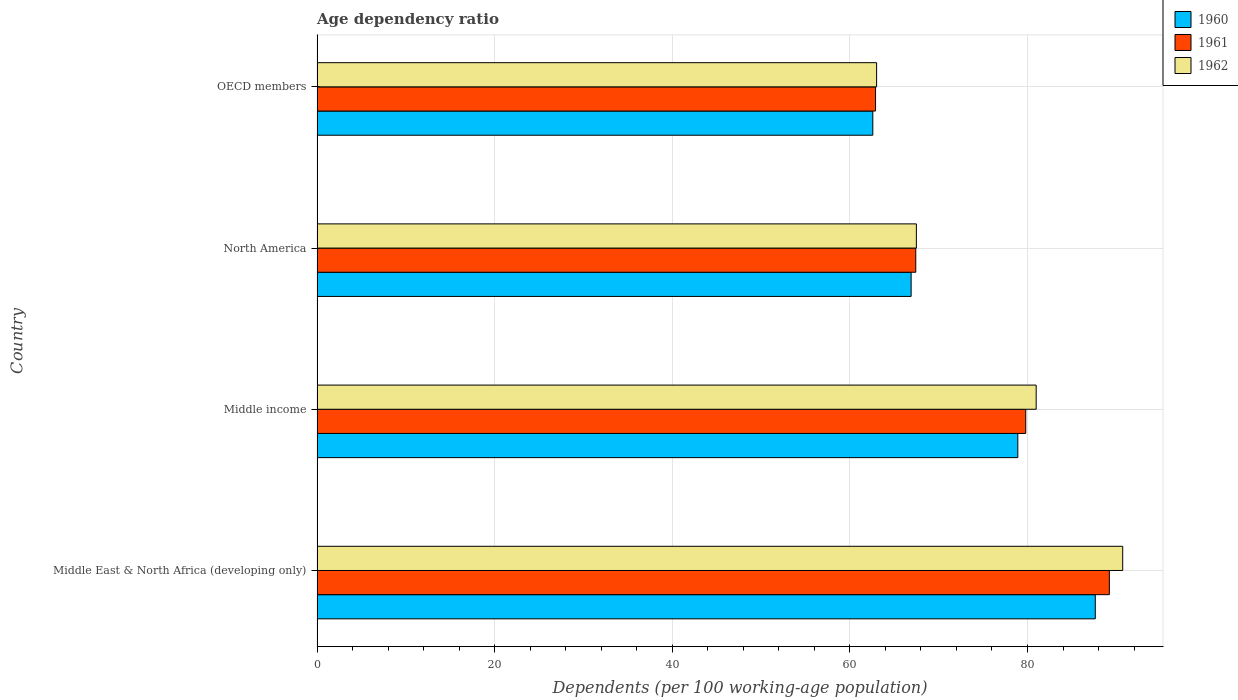How many groups of bars are there?
Your answer should be very brief. 4. Are the number of bars per tick equal to the number of legend labels?
Make the answer very short. Yes. Are the number of bars on each tick of the Y-axis equal?
Offer a terse response. Yes. How many bars are there on the 3rd tick from the top?
Your answer should be compact. 3. What is the label of the 3rd group of bars from the top?
Ensure brevity in your answer.  Middle income. What is the age dependency ratio in in 1962 in Middle East & North Africa (developing only)?
Provide a short and direct response. 90.72. Across all countries, what is the maximum age dependency ratio in in 1960?
Offer a very short reply. 87.64. Across all countries, what is the minimum age dependency ratio in in 1960?
Offer a terse response. 62.58. In which country was the age dependency ratio in in 1962 maximum?
Keep it short and to the point. Middle East & North Africa (developing only). What is the total age dependency ratio in in 1962 in the graph?
Your answer should be very brief. 302.2. What is the difference between the age dependency ratio in in 1961 in Middle East & North Africa (developing only) and that in Middle income?
Ensure brevity in your answer.  9.41. What is the difference between the age dependency ratio in in 1961 in Middle income and the age dependency ratio in in 1962 in OECD members?
Make the answer very short. 16.79. What is the average age dependency ratio in in 1961 per country?
Make the answer very short. 74.83. What is the difference between the age dependency ratio in in 1962 and age dependency ratio in in 1961 in North America?
Your answer should be compact. 0.07. In how many countries, is the age dependency ratio in in 1961 greater than 52 %?
Offer a terse response. 4. What is the ratio of the age dependency ratio in in 1962 in Middle income to that in North America?
Your answer should be compact. 1.2. Is the age dependency ratio in in 1960 in Middle East & North Africa (developing only) less than that in North America?
Keep it short and to the point. No. What is the difference between the highest and the second highest age dependency ratio in in 1961?
Provide a short and direct response. 9.41. What is the difference between the highest and the lowest age dependency ratio in in 1961?
Keep it short and to the point. 26.33. In how many countries, is the age dependency ratio in in 1961 greater than the average age dependency ratio in in 1961 taken over all countries?
Give a very brief answer. 2. What does the 2nd bar from the bottom in North America represents?
Your answer should be very brief. 1961. Is it the case that in every country, the sum of the age dependency ratio in in 1960 and age dependency ratio in in 1961 is greater than the age dependency ratio in in 1962?
Ensure brevity in your answer.  Yes. How many bars are there?
Provide a succinct answer. 12. Are all the bars in the graph horizontal?
Your response must be concise. Yes. What is the difference between two consecutive major ticks on the X-axis?
Keep it short and to the point. 20. How are the legend labels stacked?
Make the answer very short. Vertical. What is the title of the graph?
Provide a succinct answer. Age dependency ratio. What is the label or title of the X-axis?
Offer a very short reply. Dependents (per 100 working-age population). What is the Dependents (per 100 working-age population) in 1960 in Middle East & North Africa (developing only)?
Your answer should be compact. 87.64. What is the Dependents (per 100 working-age population) of 1961 in Middle East & North Africa (developing only)?
Ensure brevity in your answer.  89.22. What is the Dependents (per 100 working-age population) in 1962 in Middle East & North Africa (developing only)?
Give a very brief answer. 90.72. What is the Dependents (per 100 working-age population) in 1960 in Middle income?
Your answer should be very brief. 78.91. What is the Dependents (per 100 working-age population) of 1961 in Middle income?
Make the answer very short. 79.8. What is the Dependents (per 100 working-age population) of 1962 in Middle income?
Your response must be concise. 80.98. What is the Dependents (per 100 working-age population) of 1960 in North America?
Ensure brevity in your answer.  66.9. What is the Dependents (per 100 working-age population) of 1961 in North America?
Your answer should be compact. 67.42. What is the Dependents (per 100 working-age population) in 1962 in North America?
Keep it short and to the point. 67.49. What is the Dependents (per 100 working-age population) in 1960 in OECD members?
Provide a short and direct response. 62.58. What is the Dependents (per 100 working-age population) of 1961 in OECD members?
Your answer should be compact. 62.89. What is the Dependents (per 100 working-age population) in 1962 in OECD members?
Keep it short and to the point. 63.01. Across all countries, what is the maximum Dependents (per 100 working-age population) of 1960?
Your answer should be very brief. 87.64. Across all countries, what is the maximum Dependents (per 100 working-age population) of 1961?
Your answer should be compact. 89.22. Across all countries, what is the maximum Dependents (per 100 working-age population) in 1962?
Make the answer very short. 90.72. Across all countries, what is the minimum Dependents (per 100 working-age population) in 1960?
Provide a succinct answer. 62.58. Across all countries, what is the minimum Dependents (per 100 working-age population) in 1961?
Your answer should be very brief. 62.89. Across all countries, what is the minimum Dependents (per 100 working-age population) in 1962?
Offer a very short reply. 63.01. What is the total Dependents (per 100 working-age population) in 1960 in the graph?
Your response must be concise. 296.03. What is the total Dependents (per 100 working-age population) of 1961 in the graph?
Keep it short and to the point. 299.33. What is the total Dependents (per 100 working-age population) of 1962 in the graph?
Provide a succinct answer. 302.2. What is the difference between the Dependents (per 100 working-age population) of 1960 in Middle East & North Africa (developing only) and that in Middle income?
Provide a succinct answer. 8.72. What is the difference between the Dependents (per 100 working-age population) in 1961 in Middle East & North Africa (developing only) and that in Middle income?
Give a very brief answer. 9.41. What is the difference between the Dependents (per 100 working-age population) in 1962 in Middle East & North Africa (developing only) and that in Middle income?
Your response must be concise. 9.74. What is the difference between the Dependents (per 100 working-age population) of 1960 in Middle East & North Africa (developing only) and that in North America?
Provide a short and direct response. 20.74. What is the difference between the Dependents (per 100 working-age population) in 1961 in Middle East & North Africa (developing only) and that in North America?
Your answer should be very brief. 21.8. What is the difference between the Dependents (per 100 working-age population) in 1962 in Middle East & North Africa (developing only) and that in North America?
Offer a very short reply. 23.23. What is the difference between the Dependents (per 100 working-age population) of 1960 in Middle East & North Africa (developing only) and that in OECD members?
Your answer should be very brief. 25.05. What is the difference between the Dependents (per 100 working-age population) in 1961 in Middle East & North Africa (developing only) and that in OECD members?
Provide a succinct answer. 26.33. What is the difference between the Dependents (per 100 working-age population) of 1962 in Middle East & North Africa (developing only) and that in OECD members?
Your response must be concise. 27.71. What is the difference between the Dependents (per 100 working-age population) of 1960 in Middle income and that in North America?
Ensure brevity in your answer.  12.01. What is the difference between the Dependents (per 100 working-age population) in 1961 in Middle income and that in North America?
Make the answer very short. 12.38. What is the difference between the Dependents (per 100 working-age population) of 1962 in Middle income and that in North America?
Ensure brevity in your answer.  13.49. What is the difference between the Dependents (per 100 working-age population) of 1960 in Middle income and that in OECD members?
Give a very brief answer. 16.33. What is the difference between the Dependents (per 100 working-age population) of 1961 in Middle income and that in OECD members?
Your response must be concise. 16.91. What is the difference between the Dependents (per 100 working-age population) in 1962 in Middle income and that in OECD members?
Your answer should be compact. 17.97. What is the difference between the Dependents (per 100 working-age population) of 1960 in North America and that in OECD members?
Provide a short and direct response. 4.31. What is the difference between the Dependents (per 100 working-age population) of 1961 in North America and that in OECD members?
Your response must be concise. 4.53. What is the difference between the Dependents (per 100 working-age population) of 1962 in North America and that in OECD members?
Ensure brevity in your answer.  4.48. What is the difference between the Dependents (per 100 working-age population) in 1960 in Middle East & North Africa (developing only) and the Dependents (per 100 working-age population) in 1961 in Middle income?
Provide a succinct answer. 7.83. What is the difference between the Dependents (per 100 working-age population) in 1960 in Middle East & North Africa (developing only) and the Dependents (per 100 working-age population) in 1962 in Middle income?
Provide a short and direct response. 6.66. What is the difference between the Dependents (per 100 working-age population) in 1961 in Middle East & North Africa (developing only) and the Dependents (per 100 working-age population) in 1962 in Middle income?
Your answer should be very brief. 8.24. What is the difference between the Dependents (per 100 working-age population) of 1960 in Middle East & North Africa (developing only) and the Dependents (per 100 working-age population) of 1961 in North America?
Provide a succinct answer. 20.22. What is the difference between the Dependents (per 100 working-age population) of 1960 in Middle East & North Africa (developing only) and the Dependents (per 100 working-age population) of 1962 in North America?
Offer a very short reply. 20.15. What is the difference between the Dependents (per 100 working-age population) of 1961 in Middle East & North Africa (developing only) and the Dependents (per 100 working-age population) of 1962 in North America?
Offer a terse response. 21.73. What is the difference between the Dependents (per 100 working-age population) in 1960 in Middle East & North Africa (developing only) and the Dependents (per 100 working-age population) in 1961 in OECD members?
Provide a succinct answer. 24.74. What is the difference between the Dependents (per 100 working-age population) in 1960 in Middle East & North Africa (developing only) and the Dependents (per 100 working-age population) in 1962 in OECD members?
Give a very brief answer. 24.62. What is the difference between the Dependents (per 100 working-age population) of 1961 in Middle East & North Africa (developing only) and the Dependents (per 100 working-age population) of 1962 in OECD members?
Offer a terse response. 26.21. What is the difference between the Dependents (per 100 working-age population) of 1960 in Middle income and the Dependents (per 100 working-age population) of 1961 in North America?
Your answer should be very brief. 11.49. What is the difference between the Dependents (per 100 working-age population) in 1960 in Middle income and the Dependents (per 100 working-age population) in 1962 in North America?
Your answer should be compact. 11.42. What is the difference between the Dependents (per 100 working-age population) in 1961 in Middle income and the Dependents (per 100 working-age population) in 1962 in North America?
Provide a short and direct response. 12.31. What is the difference between the Dependents (per 100 working-age population) of 1960 in Middle income and the Dependents (per 100 working-age population) of 1961 in OECD members?
Keep it short and to the point. 16.02. What is the difference between the Dependents (per 100 working-age population) in 1960 in Middle income and the Dependents (per 100 working-age population) in 1962 in OECD members?
Ensure brevity in your answer.  15.9. What is the difference between the Dependents (per 100 working-age population) of 1961 in Middle income and the Dependents (per 100 working-age population) of 1962 in OECD members?
Your answer should be very brief. 16.79. What is the difference between the Dependents (per 100 working-age population) of 1960 in North America and the Dependents (per 100 working-age population) of 1961 in OECD members?
Your response must be concise. 4.01. What is the difference between the Dependents (per 100 working-age population) in 1960 in North America and the Dependents (per 100 working-age population) in 1962 in OECD members?
Give a very brief answer. 3.89. What is the difference between the Dependents (per 100 working-age population) in 1961 in North America and the Dependents (per 100 working-age population) in 1962 in OECD members?
Your response must be concise. 4.41. What is the average Dependents (per 100 working-age population) of 1960 per country?
Ensure brevity in your answer.  74.01. What is the average Dependents (per 100 working-age population) of 1961 per country?
Ensure brevity in your answer.  74.83. What is the average Dependents (per 100 working-age population) of 1962 per country?
Offer a terse response. 75.55. What is the difference between the Dependents (per 100 working-age population) of 1960 and Dependents (per 100 working-age population) of 1961 in Middle East & North Africa (developing only)?
Your response must be concise. -1.58. What is the difference between the Dependents (per 100 working-age population) of 1960 and Dependents (per 100 working-age population) of 1962 in Middle East & North Africa (developing only)?
Your answer should be compact. -3.09. What is the difference between the Dependents (per 100 working-age population) in 1961 and Dependents (per 100 working-age population) in 1962 in Middle East & North Africa (developing only)?
Your answer should be compact. -1.51. What is the difference between the Dependents (per 100 working-age population) of 1960 and Dependents (per 100 working-age population) of 1961 in Middle income?
Your response must be concise. -0.89. What is the difference between the Dependents (per 100 working-age population) in 1960 and Dependents (per 100 working-age population) in 1962 in Middle income?
Your answer should be compact. -2.07. What is the difference between the Dependents (per 100 working-age population) of 1961 and Dependents (per 100 working-age population) of 1962 in Middle income?
Offer a terse response. -1.18. What is the difference between the Dependents (per 100 working-age population) in 1960 and Dependents (per 100 working-age population) in 1961 in North America?
Provide a short and direct response. -0.52. What is the difference between the Dependents (per 100 working-age population) of 1960 and Dependents (per 100 working-age population) of 1962 in North America?
Keep it short and to the point. -0.59. What is the difference between the Dependents (per 100 working-age population) of 1961 and Dependents (per 100 working-age population) of 1962 in North America?
Your answer should be very brief. -0.07. What is the difference between the Dependents (per 100 working-age population) of 1960 and Dependents (per 100 working-age population) of 1961 in OECD members?
Offer a very short reply. -0.31. What is the difference between the Dependents (per 100 working-age population) of 1960 and Dependents (per 100 working-age population) of 1962 in OECD members?
Provide a short and direct response. -0.43. What is the difference between the Dependents (per 100 working-age population) of 1961 and Dependents (per 100 working-age population) of 1962 in OECD members?
Make the answer very short. -0.12. What is the ratio of the Dependents (per 100 working-age population) of 1960 in Middle East & North Africa (developing only) to that in Middle income?
Your answer should be compact. 1.11. What is the ratio of the Dependents (per 100 working-age population) in 1961 in Middle East & North Africa (developing only) to that in Middle income?
Your answer should be compact. 1.12. What is the ratio of the Dependents (per 100 working-age population) in 1962 in Middle East & North Africa (developing only) to that in Middle income?
Give a very brief answer. 1.12. What is the ratio of the Dependents (per 100 working-age population) in 1960 in Middle East & North Africa (developing only) to that in North America?
Ensure brevity in your answer.  1.31. What is the ratio of the Dependents (per 100 working-age population) in 1961 in Middle East & North Africa (developing only) to that in North America?
Provide a short and direct response. 1.32. What is the ratio of the Dependents (per 100 working-age population) of 1962 in Middle East & North Africa (developing only) to that in North America?
Provide a succinct answer. 1.34. What is the ratio of the Dependents (per 100 working-age population) in 1960 in Middle East & North Africa (developing only) to that in OECD members?
Your answer should be very brief. 1.4. What is the ratio of the Dependents (per 100 working-age population) in 1961 in Middle East & North Africa (developing only) to that in OECD members?
Offer a very short reply. 1.42. What is the ratio of the Dependents (per 100 working-age population) in 1962 in Middle East & North Africa (developing only) to that in OECD members?
Your answer should be very brief. 1.44. What is the ratio of the Dependents (per 100 working-age population) of 1960 in Middle income to that in North America?
Give a very brief answer. 1.18. What is the ratio of the Dependents (per 100 working-age population) of 1961 in Middle income to that in North America?
Give a very brief answer. 1.18. What is the ratio of the Dependents (per 100 working-age population) in 1962 in Middle income to that in North America?
Your answer should be compact. 1.2. What is the ratio of the Dependents (per 100 working-age population) in 1960 in Middle income to that in OECD members?
Ensure brevity in your answer.  1.26. What is the ratio of the Dependents (per 100 working-age population) of 1961 in Middle income to that in OECD members?
Your answer should be very brief. 1.27. What is the ratio of the Dependents (per 100 working-age population) of 1962 in Middle income to that in OECD members?
Keep it short and to the point. 1.29. What is the ratio of the Dependents (per 100 working-age population) of 1960 in North America to that in OECD members?
Keep it short and to the point. 1.07. What is the ratio of the Dependents (per 100 working-age population) of 1961 in North America to that in OECD members?
Keep it short and to the point. 1.07. What is the ratio of the Dependents (per 100 working-age population) in 1962 in North America to that in OECD members?
Give a very brief answer. 1.07. What is the difference between the highest and the second highest Dependents (per 100 working-age population) in 1960?
Your response must be concise. 8.72. What is the difference between the highest and the second highest Dependents (per 100 working-age population) in 1961?
Keep it short and to the point. 9.41. What is the difference between the highest and the second highest Dependents (per 100 working-age population) in 1962?
Provide a succinct answer. 9.74. What is the difference between the highest and the lowest Dependents (per 100 working-age population) in 1960?
Offer a very short reply. 25.05. What is the difference between the highest and the lowest Dependents (per 100 working-age population) of 1961?
Offer a terse response. 26.33. What is the difference between the highest and the lowest Dependents (per 100 working-age population) of 1962?
Provide a short and direct response. 27.71. 